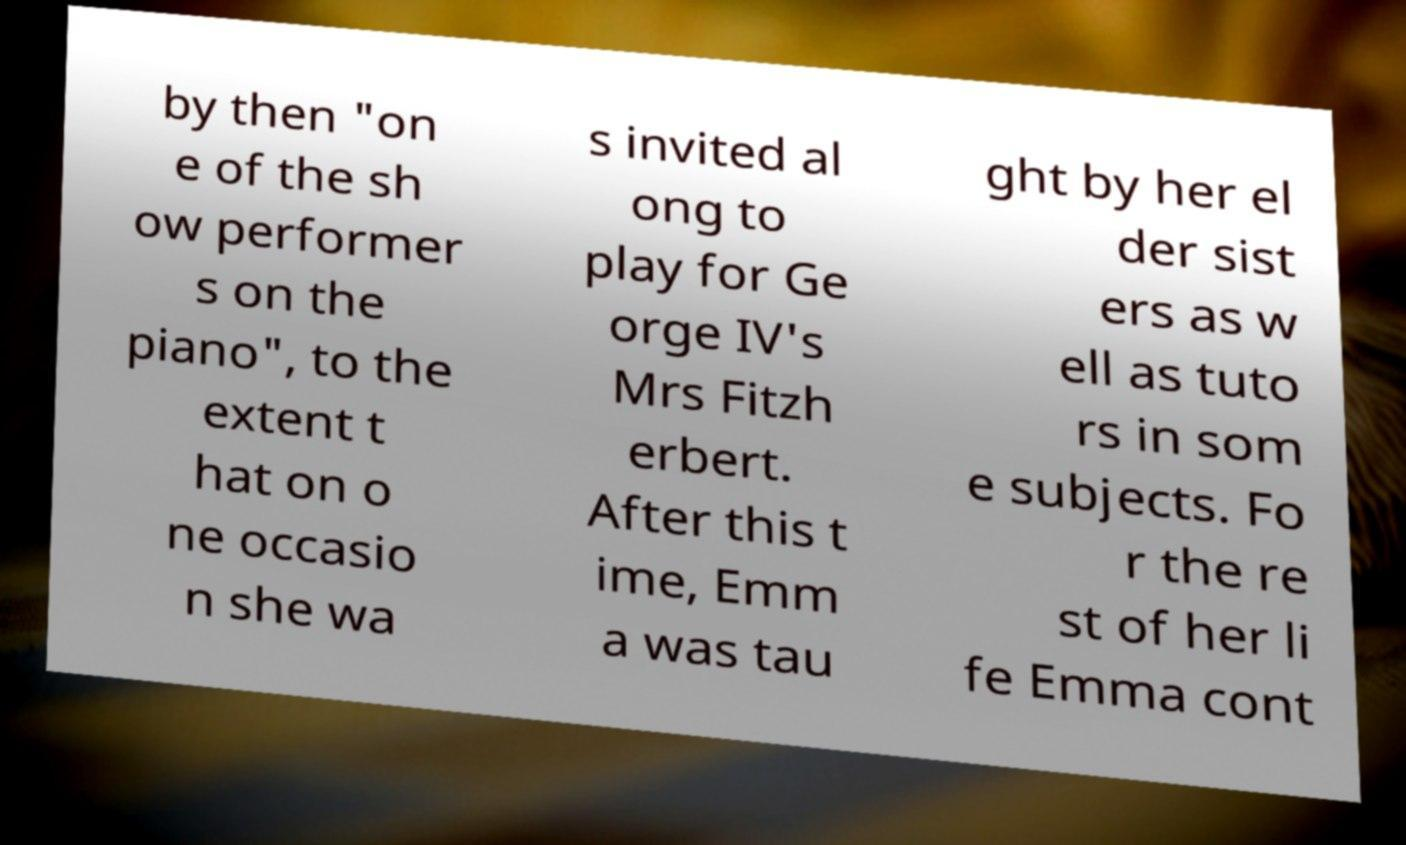For documentation purposes, I need the text within this image transcribed. Could you provide that? by then "on e of the sh ow performer s on the piano", to the extent t hat on o ne occasio n she wa s invited al ong to play for Ge orge IV's Mrs Fitzh erbert. After this t ime, Emm a was tau ght by her el der sist ers as w ell as tuto rs in som e subjects. Fo r the re st of her li fe Emma cont 